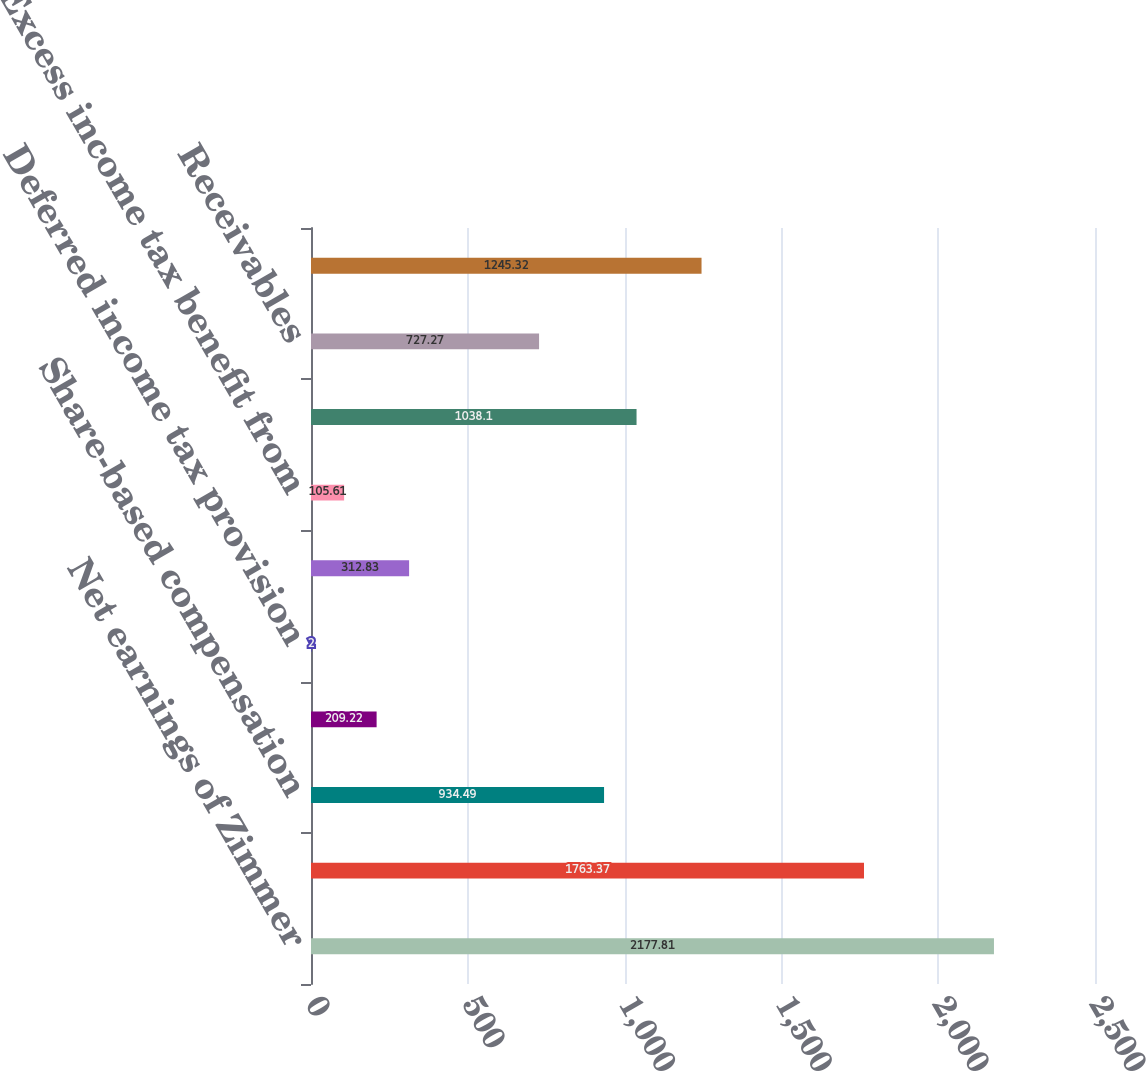Convert chart to OTSL. <chart><loc_0><loc_0><loc_500><loc_500><bar_chart><fcel>Net earnings of Zimmer<fcel>Depreciation and amortization<fcel>Share-based compensation<fcel>Inventory step-up<fcel>Deferred income tax provision<fcel>Income tax benefit from stock<fcel>Excess income tax benefit from<fcel>Income taxes payable<fcel>Receivables<fcel>Inventories<nl><fcel>2177.81<fcel>1763.37<fcel>934.49<fcel>209.22<fcel>2<fcel>312.83<fcel>105.61<fcel>1038.1<fcel>727.27<fcel>1245.32<nl></chart> 